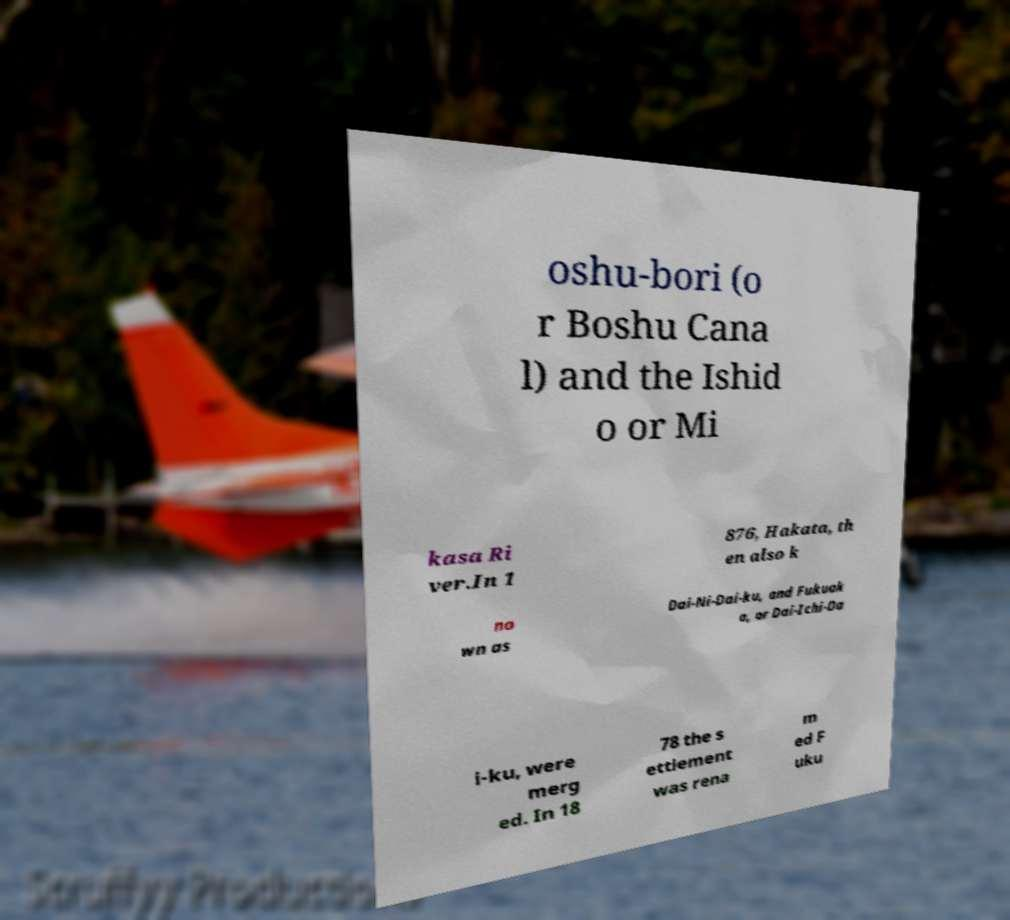Could you assist in decoding the text presented in this image and type it out clearly? oshu-bori (o r Boshu Cana l) and the Ishid o or Mi kasa Ri ver.In 1 876, Hakata, th en also k no wn as Dai-Ni-Dai-ku, and Fukuok a, or Dai-Ichi-Da i-ku, were merg ed. In 18 78 the s ettlement was rena m ed F uku 